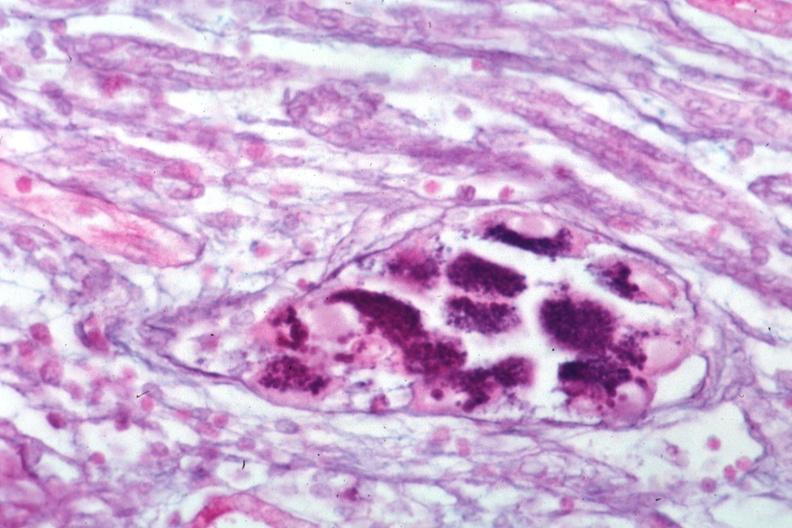what does this image show?
Answer the question using a single word or phrase. Pas-alcian blue 